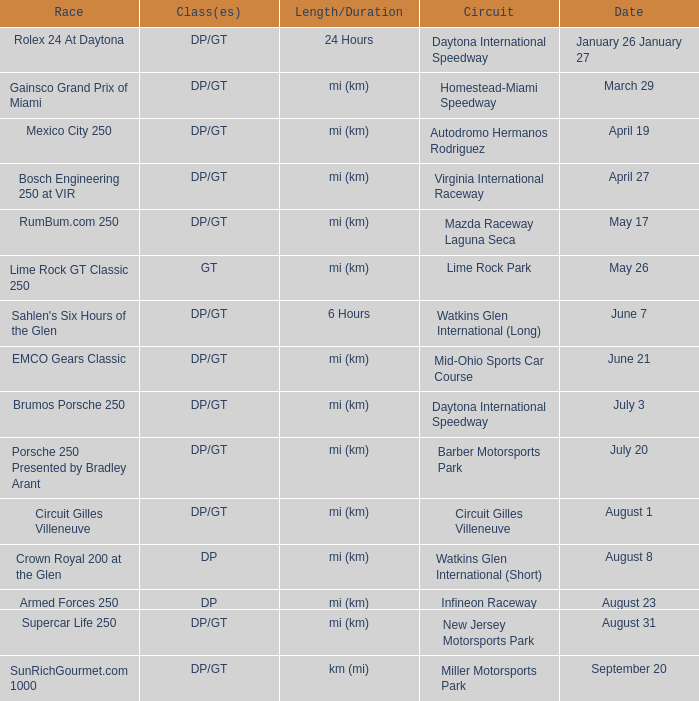What is the length and duration of the race on April 19? Mi (km). 